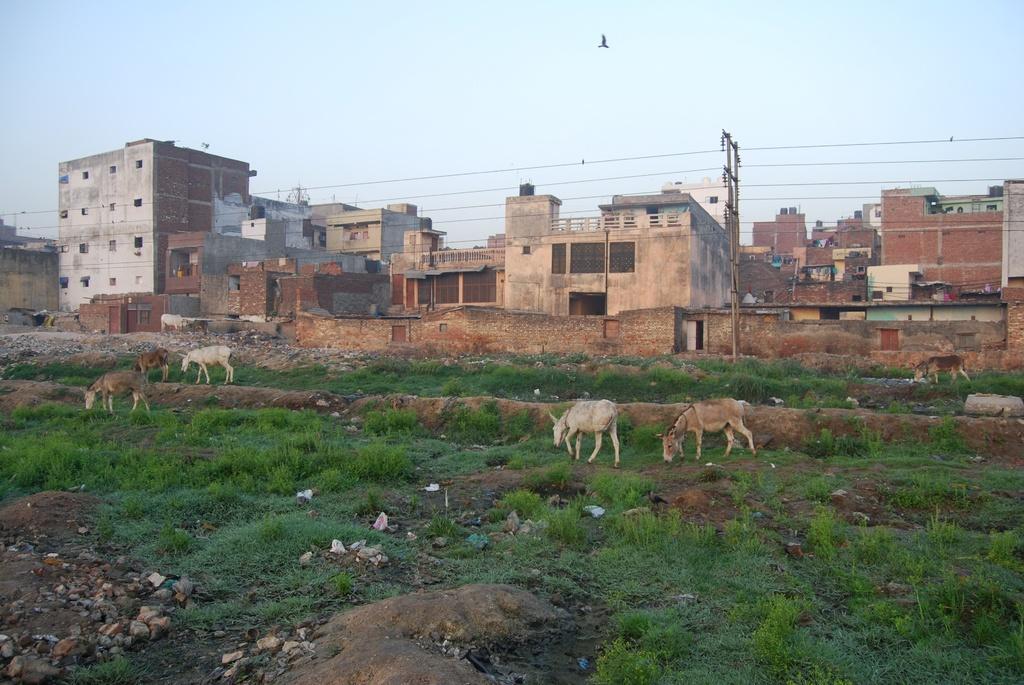Describe this image in one or two sentences. In this image we can see animals and grass on the land. In the background, we can see buildings, pole and wires. We can see a bird in the sky at the top of the image. 